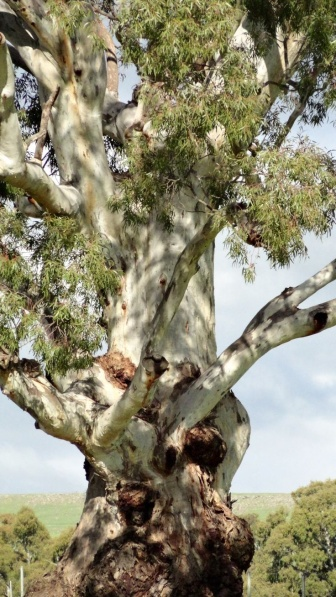What might this tree's presence indicate about the local climate and soil conditions? The robust health of this tree, with its substantial foliage and apparent growth despite the presence of burls, suggests that the local climate and soil conditions are conducive to its prosperity. As eucalyptus trees generally favor a well-drained, nutrient-rich soil and a climate with moderate to high rainfall, this setting likely reflects such an environment. Furthermore, these trees are used to periods of dryness, implying that the area might have a climate with distinct wet and dry seasons. 